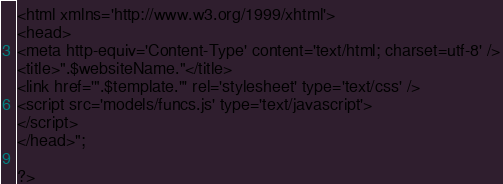<code> <loc_0><loc_0><loc_500><loc_500><_PHP_><html xmlns='http://www.w3.org/1999/xhtml'>
<head>
<meta http-equiv='Content-Type' content='text/html; charset=utf-8' />
<title>".$websiteName."</title>
<link href='".$template."' rel='stylesheet' type='text/css' />
<script src='models/funcs.js' type='text/javascript'>
</script>
</head>";

?>


</code> 